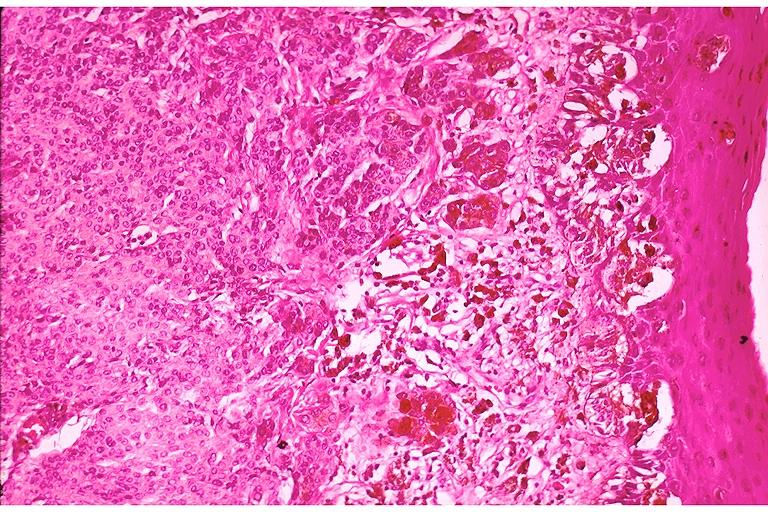does bilateral cleft palate show compound nevus?
Answer the question using a single word or phrase. No 